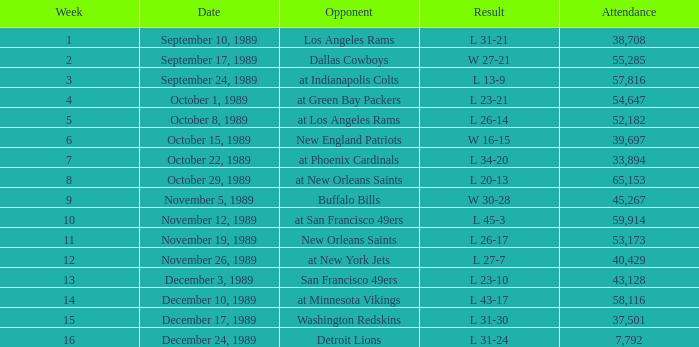The Detroit Lions were played against what week? 16.0. 